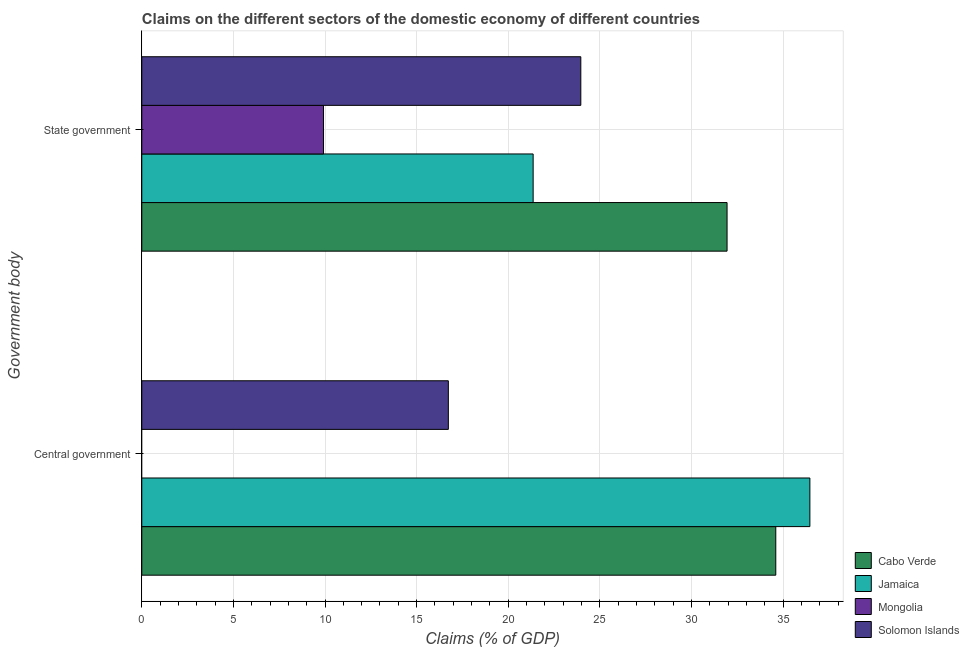How many different coloured bars are there?
Your answer should be very brief. 4. Are the number of bars per tick equal to the number of legend labels?
Provide a succinct answer. No. Are the number of bars on each tick of the Y-axis equal?
Your answer should be very brief. No. How many bars are there on the 2nd tick from the bottom?
Give a very brief answer. 4. What is the label of the 2nd group of bars from the top?
Make the answer very short. Central government. What is the claims on central government in Solomon Islands?
Your answer should be compact. 16.73. Across all countries, what is the maximum claims on central government?
Give a very brief answer. 36.46. Across all countries, what is the minimum claims on central government?
Provide a succinct answer. 0. In which country was the claims on state government maximum?
Provide a short and direct response. Cabo Verde. What is the total claims on state government in the graph?
Ensure brevity in your answer.  87.18. What is the difference between the claims on central government in Cabo Verde and that in Solomon Islands?
Make the answer very short. 17.87. What is the difference between the claims on state government in Jamaica and the claims on central government in Mongolia?
Ensure brevity in your answer.  21.36. What is the average claims on central government per country?
Keep it short and to the point. 21.95. What is the difference between the claims on central government and claims on state government in Solomon Islands?
Offer a very short reply. -7.23. What is the ratio of the claims on state government in Solomon Islands to that in Mongolia?
Your answer should be compact. 2.42. Is the claims on state government in Cabo Verde less than that in Mongolia?
Give a very brief answer. No. How many countries are there in the graph?
Your response must be concise. 4. Does the graph contain grids?
Offer a terse response. Yes. How many legend labels are there?
Offer a very short reply. 4. How are the legend labels stacked?
Provide a succinct answer. Vertical. What is the title of the graph?
Give a very brief answer. Claims on the different sectors of the domestic economy of different countries. Does "Spain" appear as one of the legend labels in the graph?
Keep it short and to the point. No. What is the label or title of the X-axis?
Ensure brevity in your answer.  Claims (% of GDP). What is the label or title of the Y-axis?
Keep it short and to the point. Government body. What is the Claims (% of GDP) of Cabo Verde in Central government?
Offer a terse response. 34.6. What is the Claims (% of GDP) of Jamaica in Central government?
Ensure brevity in your answer.  36.46. What is the Claims (% of GDP) of Solomon Islands in Central government?
Make the answer very short. 16.73. What is the Claims (% of GDP) of Cabo Verde in State government?
Your answer should be compact. 31.94. What is the Claims (% of GDP) of Jamaica in State government?
Your answer should be very brief. 21.36. What is the Claims (% of GDP) in Mongolia in State government?
Offer a terse response. 9.92. What is the Claims (% of GDP) in Solomon Islands in State government?
Make the answer very short. 23.96. Across all Government body, what is the maximum Claims (% of GDP) of Cabo Verde?
Your answer should be very brief. 34.6. Across all Government body, what is the maximum Claims (% of GDP) in Jamaica?
Provide a succinct answer. 36.46. Across all Government body, what is the maximum Claims (% of GDP) in Mongolia?
Give a very brief answer. 9.92. Across all Government body, what is the maximum Claims (% of GDP) in Solomon Islands?
Make the answer very short. 23.96. Across all Government body, what is the minimum Claims (% of GDP) in Cabo Verde?
Provide a succinct answer. 31.94. Across all Government body, what is the minimum Claims (% of GDP) in Jamaica?
Your answer should be very brief. 21.36. Across all Government body, what is the minimum Claims (% of GDP) in Solomon Islands?
Your response must be concise. 16.73. What is the total Claims (% of GDP) of Cabo Verde in the graph?
Give a very brief answer. 66.55. What is the total Claims (% of GDP) in Jamaica in the graph?
Offer a very short reply. 57.82. What is the total Claims (% of GDP) of Mongolia in the graph?
Ensure brevity in your answer.  9.92. What is the total Claims (% of GDP) in Solomon Islands in the graph?
Provide a short and direct response. 40.69. What is the difference between the Claims (% of GDP) in Cabo Verde in Central government and that in State government?
Give a very brief answer. 2.66. What is the difference between the Claims (% of GDP) in Jamaica in Central government and that in State government?
Provide a short and direct response. 15.1. What is the difference between the Claims (% of GDP) in Solomon Islands in Central government and that in State government?
Keep it short and to the point. -7.23. What is the difference between the Claims (% of GDP) in Cabo Verde in Central government and the Claims (% of GDP) in Jamaica in State government?
Offer a very short reply. 13.24. What is the difference between the Claims (% of GDP) in Cabo Verde in Central government and the Claims (% of GDP) in Mongolia in State government?
Ensure brevity in your answer.  24.68. What is the difference between the Claims (% of GDP) of Cabo Verde in Central government and the Claims (% of GDP) of Solomon Islands in State government?
Offer a terse response. 10.64. What is the difference between the Claims (% of GDP) in Jamaica in Central government and the Claims (% of GDP) in Mongolia in State government?
Provide a short and direct response. 26.54. What is the difference between the Claims (% of GDP) in Jamaica in Central government and the Claims (% of GDP) in Solomon Islands in State government?
Provide a succinct answer. 12.5. What is the average Claims (% of GDP) in Cabo Verde per Government body?
Offer a very short reply. 33.27. What is the average Claims (% of GDP) in Jamaica per Government body?
Your response must be concise. 28.91. What is the average Claims (% of GDP) of Mongolia per Government body?
Provide a succinct answer. 4.96. What is the average Claims (% of GDP) of Solomon Islands per Government body?
Keep it short and to the point. 20.35. What is the difference between the Claims (% of GDP) in Cabo Verde and Claims (% of GDP) in Jamaica in Central government?
Make the answer very short. -1.86. What is the difference between the Claims (% of GDP) in Cabo Verde and Claims (% of GDP) in Solomon Islands in Central government?
Provide a short and direct response. 17.87. What is the difference between the Claims (% of GDP) in Jamaica and Claims (% of GDP) in Solomon Islands in Central government?
Offer a very short reply. 19.73. What is the difference between the Claims (% of GDP) of Cabo Verde and Claims (% of GDP) of Jamaica in State government?
Provide a short and direct response. 10.58. What is the difference between the Claims (% of GDP) of Cabo Verde and Claims (% of GDP) of Mongolia in State government?
Make the answer very short. 22.02. What is the difference between the Claims (% of GDP) of Cabo Verde and Claims (% of GDP) of Solomon Islands in State government?
Ensure brevity in your answer.  7.98. What is the difference between the Claims (% of GDP) in Jamaica and Claims (% of GDP) in Mongolia in State government?
Your answer should be compact. 11.44. What is the difference between the Claims (% of GDP) of Jamaica and Claims (% of GDP) of Solomon Islands in State government?
Keep it short and to the point. -2.6. What is the difference between the Claims (% of GDP) in Mongolia and Claims (% of GDP) in Solomon Islands in State government?
Keep it short and to the point. -14.04. What is the ratio of the Claims (% of GDP) in Cabo Verde in Central government to that in State government?
Offer a terse response. 1.08. What is the ratio of the Claims (% of GDP) of Jamaica in Central government to that in State government?
Offer a very short reply. 1.71. What is the ratio of the Claims (% of GDP) of Solomon Islands in Central government to that in State government?
Your answer should be very brief. 0.7. What is the difference between the highest and the second highest Claims (% of GDP) in Cabo Verde?
Offer a very short reply. 2.66. What is the difference between the highest and the second highest Claims (% of GDP) of Jamaica?
Ensure brevity in your answer.  15.1. What is the difference between the highest and the second highest Claims (% of GDP) in Solomon Islands?
Your answer should be very brief. 7.23. What is the difference between the highest and the lowest Claims (% of GDP) in Cabo Verde?
Your answer should be very brief. 2.66. What is the difference between the highest and the lowest Claims (% of GDP) of Jamaica?
Make the answer very short. 15.1. What is the difference between the highest and the lowest Claims (% of GDP) of Mongolia?
Ensure brevity in your answer.  9.92. What is the difference between the highest and the lowest Claims (% of GDP) in Solomon Islands?
Provide a succinct answer. 7.23. 